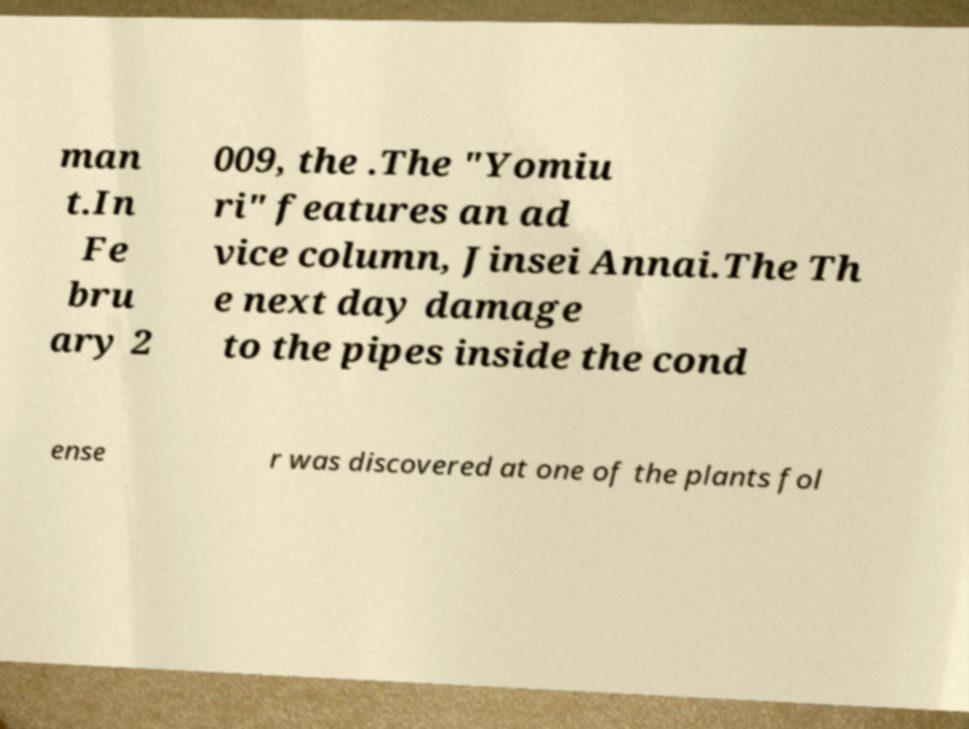Please identify and transcribe the text found in this image. man t.In Fe bru ary 2 009, the .The "Yomiu ri" features an ad vice column, Jinsei Annai.The Th e next day damage to the pipes inside the cond ense r was discovered at one of the plants fol 